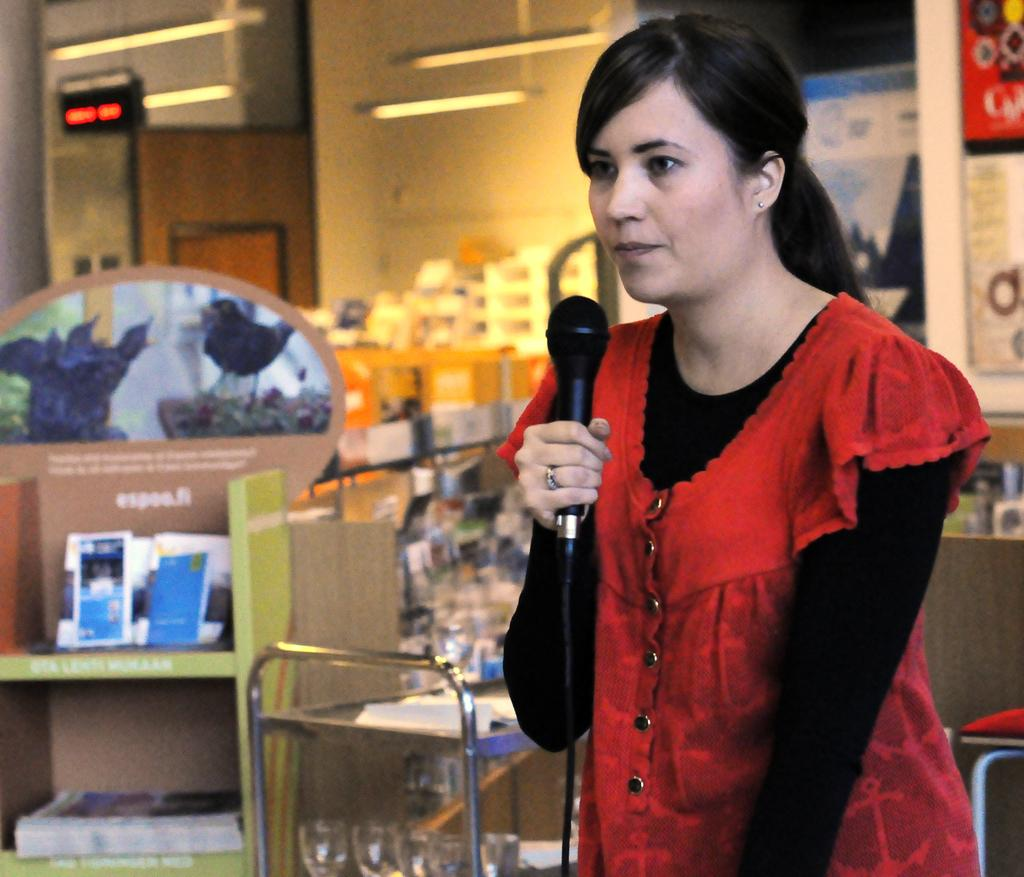Who is the main subject in the image? There is a woman in the image. What is the woman doing in the image? The woman is standing and talking into a microphone. What can be seen in the background of the image? There are books in a rack, a table, glasses, a timer, and a bulb in the background. What side of the woman is the rule being enforced on in the image? There is no rule being enforced in the image, and therefore no side of the woman is relevant to this question. 